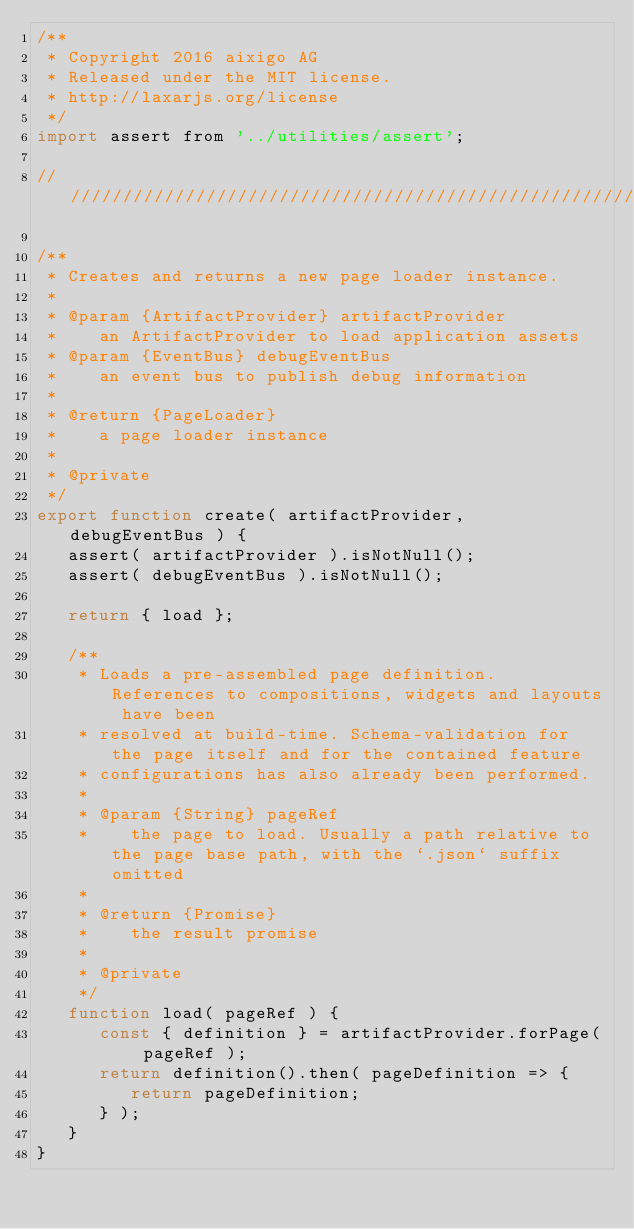Convert code to text. <code><loc_0><loc_0><loc_500><loc_500><_JavaScript_>/**
 * Copyright 2016 aixigo AG
 * Released under the MIT license.
 * http://laxarjs.org/license
 */
import assert from '../utilities/assert';

//////////////////////////////////////////////////////////////////////////////////////////////////////////////

/**
 * Creates and returns a new page loader instance.
 *
 * @param {ArtifactProvider} artifactProvider
 *    an ArtifactProvider to load application assets
 * @param {EventBus} debugEventBus
 *    an event bus to publish debug information
 *
 * @return {PageLoader}
 *    a page loader instance
 *
 * @private
 */
export function create( artifactProvider, debugEventBus ) {
   assert( artifactProvider ).isNotNull();
   assert( debugEventBus ).isNotNull();

   return { load };

   /**
    * Loads a pre-assembled page definition. References to compositions, widgets and layouts have been
    * resolved at build-time. Schema-validation for the page itself and for the contained feature
    * configurations has also already been performed.
    *
    * @param {String} pageRef
    *    the page to load. Usually a path relative to the page base path, with the `.json` suffix omitted
    *
    * @return {Promise}
    *    the result promise
    *
    * @private
    */
   function load( pageRef ) {
      const { definition } = artifactProvider.forPage( pageRef );
      return definition().then( pageDefinition => {
         return pageDefinition;
      } );
   }
}
</code> 